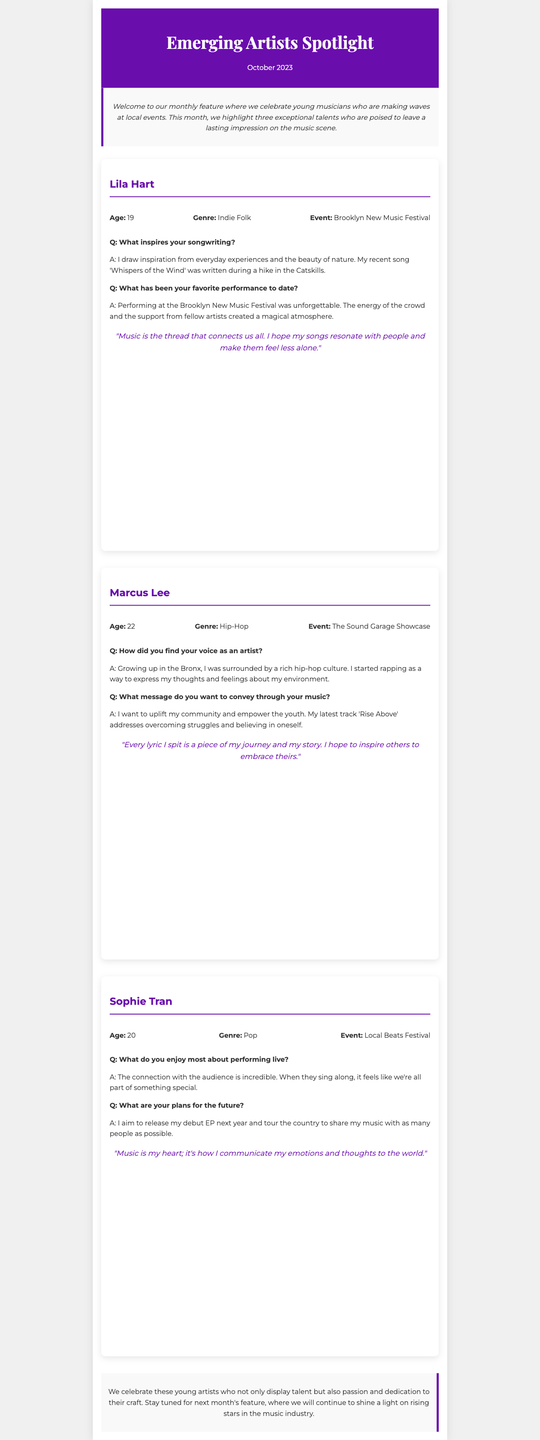What is the genre of Lila Hart? Lila Hart is identified with the Indie Folk genre in the document.
Answer: Indie Folk How old is Marcus Lee? The document states that Marcus Lee is 22 years old.
Answer: 22 What event did Sophie Tran perform at? Sophie Tran performed at the Local Beats Festival, as mentioned in her profile.
Answer: Local Beats Festival What is the title of Lila Hart's recent song? The document reveals that Lila Hart's recent song is titled "Whispers of the Wind."
Answer: Whispers of the Wind What message does Marcus Lee want to convey through his music? The document notes that Marcus Lee aims to uplift his community and empower the youth through his message.
Answer: Uplift my community and empower the youth What is Sophie Tran's plan for the future? According to the document, Sophie Tran plans to release her debut EP next year and tour the country.
Answer: Release my debut EP next year and tour Who is the featured artist of the month? The document introduces three artists, but the title of the newsletter indicates this is a monthly feature for emerging artists.
Answer: Lila Hart, Marcus Lee, Sophie Tran What quote is attributed to Sophie Tran? The document includes a quote from Sophie Tran about music being her heart, which she uses to communicate.
Answer: "Music is my heart; it's how I communicate my emotions and thoughts to the world." 